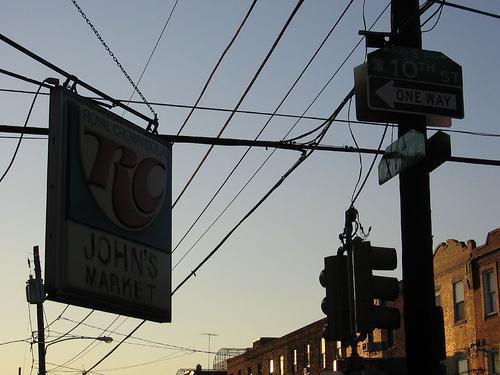How many traffic lights can you see?
Give a very brief answer. 1. 